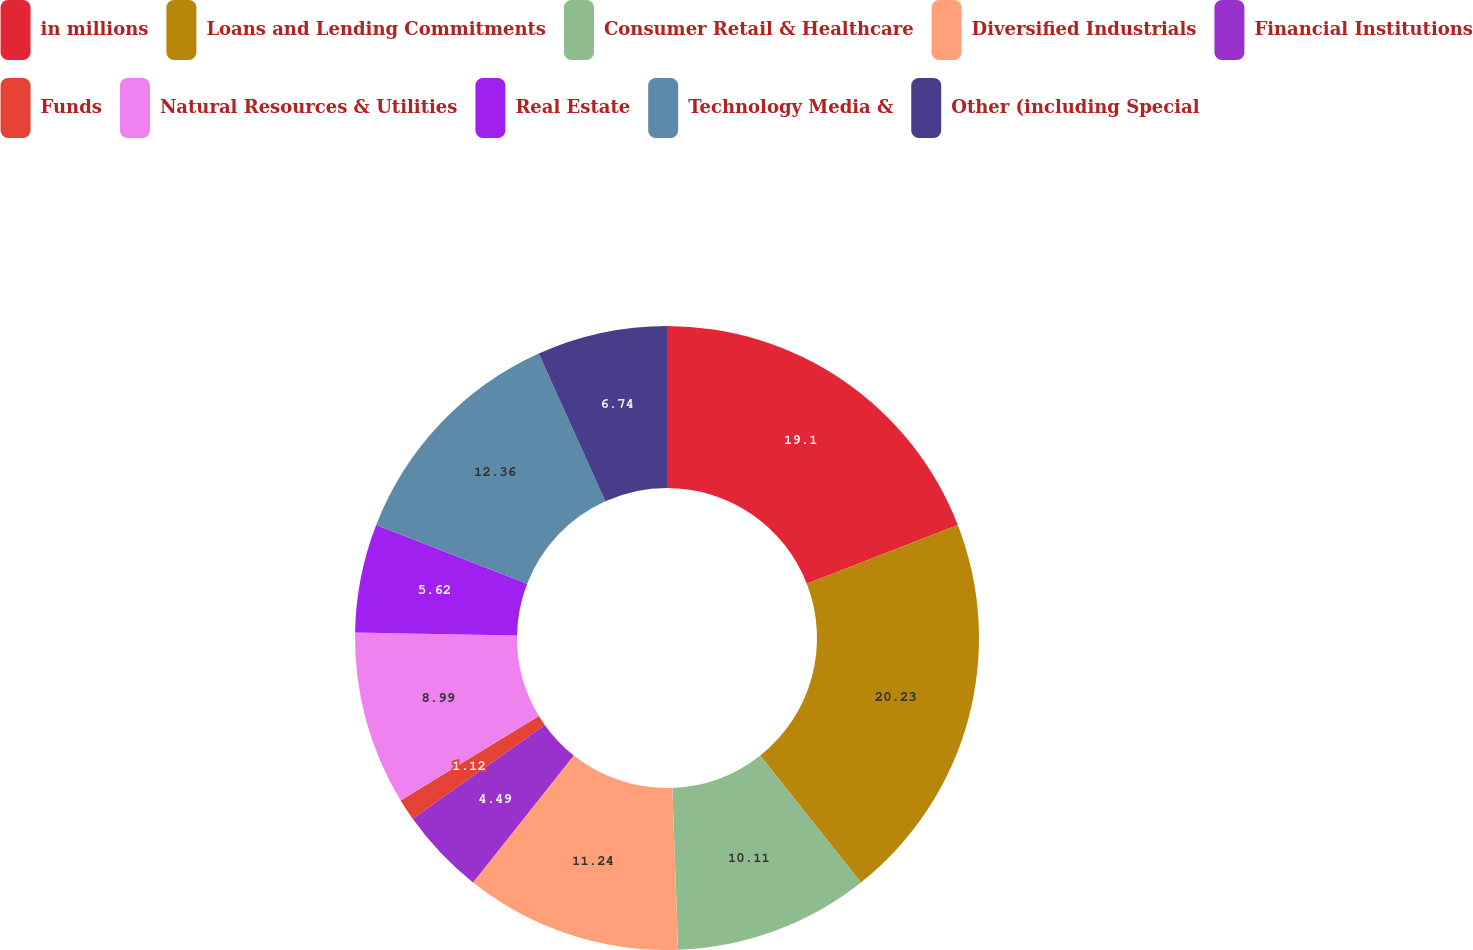Convert chart to OTSL. <chart><loc_0><loc_0><loc_500><loc_500><pie_chart><fcel>in millions<fcel>Loans and Lending Commitments<fcel>Consumer Retail & Healthcare<fcel>Diversified Industrials<fcel>Financial Institutions<fcel>Funds<fcel>Natural Resources & Utilities<fcel>Real Estate<fcel>Technology Media &<fcel>Other (including Special<nl><fcel>19.1%<fcel>20.22%<fcel>10.11%<fcel>11.24%<fcel>4.49%<fcel>1.12%<fcel>8.99%<fcel>5.62%<fcel>12.36%<fcel>6.74%<nl></chart> 